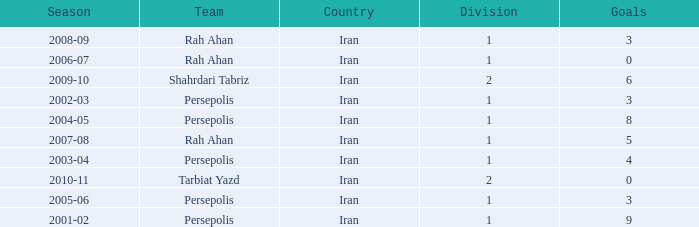What is the lowest Division, when Goals is less than 5, and when Season is "2002-03"? 1.0. Write the full table. {'header': ['Season', 'Team', 'Country', 'Division', 'Goals'], 'rows': [['2008-09', 'Rah Ahan', 'Iran', '1', '3'], ['2006-07', 'Rah Ahan', 'Iran', '1', '0'], ['2009-10', 'Shahrdari Tabriz', 'Iran', '2', '6'], ['2002-03', 'Persepolis', 'Iran', '1', '3'], ['2004-05', 'Persepolis', 'Iran', '1', '8'], ['2007-08', 'Rah Ahan', 'Iran', '1', '5'], ['2003-04', 'Persepolis', 'Iran', '1', '4'], ['2010-11', 'Tarbiat Yazd', 'Iran', '2', '0'], ['2005-06', 'Persepolis', 'Iran', '1', '3'], ['2001-02', 'Persepolis', 'Iran', '1', '9']]} 